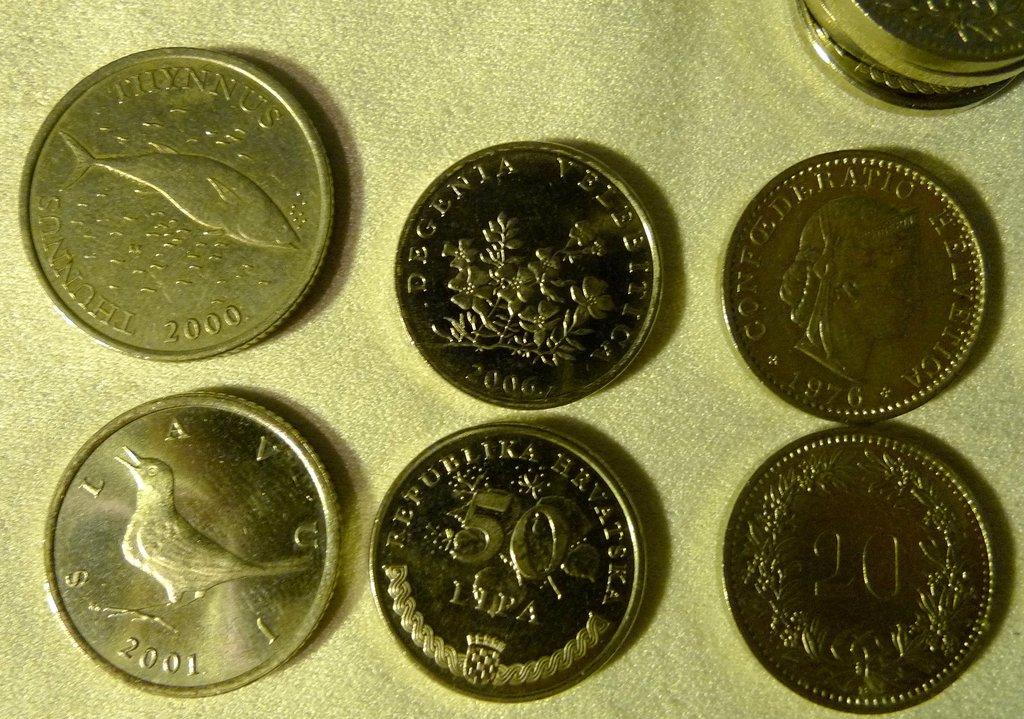What year is the coin on the bottom left?
Your answer should be very brief. 2001. 